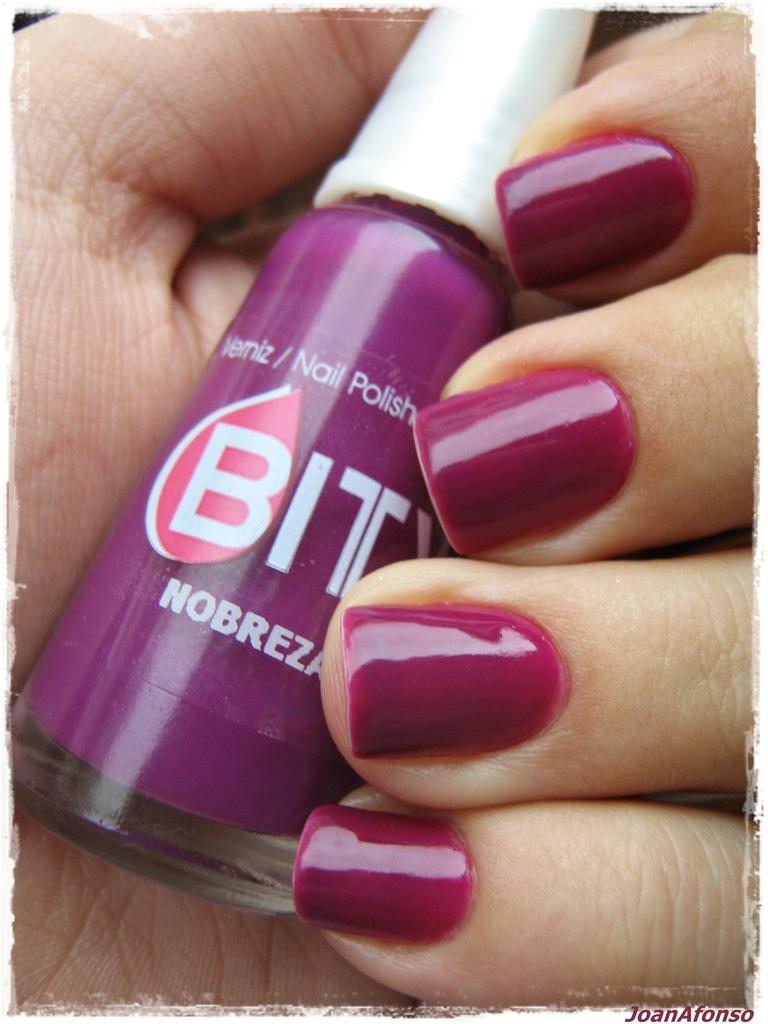What type of cosmetic product is visible in the image? There is a purple color nail polish bottle in the image. What else can be seen in the image besides the nail polish bottle? There are human fingers in the image. What is the condition of the human fingers in the image? The human fingers have nail polish on them. How does the finger slip on the mind in the image? There is no finger or mind present in the image; it only features a nail polish bottle and human fingers with nail polish. 